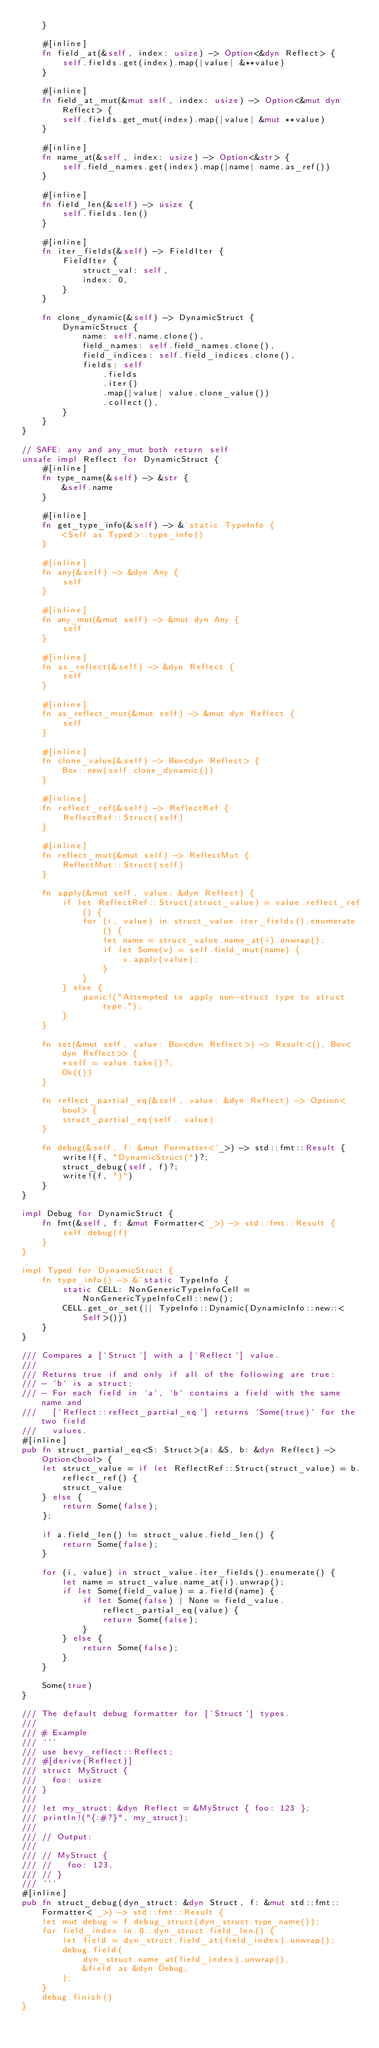Convert code to text. <code><loc_0><loc_0><loc_500><loc_500><_Rust_>    }

    #[inline]
    fn field_at(&self, index: usize) -> Option<&dyn Reflect> {
        self.fields.get(index).map(|value| &**value)
    }

    #[inline]
    fn field_at_mut(&mut self, index: usize) -> Option<&mut dyn Reflect> {
        self.fields.get_mut(index).map(|value| &mut **value)
    }

    #[inline]
    fn name_at(&self, index: usize) -> Option<&str> {
        self.field_names.get(index).map(|name| name.as_ref())
    }

    #[inline]
    fn field_len(&self) -> usize {
        self.fields.len()
    }

    #[inline]
    fn iter_fields(&self) -> FieldIter {
        FieldIter {
            struct_val: self,
            index: 0,
        }
    }

    fn clone_dynamic(&self) -> DynamicStruct {
        DynamicStruct {
            name: self.name.clone(),
            field_names: self.field_names.clone(),
            field_indices: self.field_indices.clone(),
            fields: self
                .fields
                .iter()
                .map(|value| value.clone_value())
                .collect(),
        }
    }
}

// SAFE: any and any_mut both return self
unsafe impl Reflect for DynamicStruct {
    #[inline]
    fn type_name(&self) -> &str {
        &self.name
    }

    #[inline]
    fn get_type_info(&self) -> &'static TypeInfo {
        <Self as Typed>::type_info()
    }

    #[inline]
    fn any(&self) -> &dyn Any {
        self
    }

    #[inline]
    fn any_mut(&mut self) -> &mut dyn Any {
        self
    }

    #[inline]
    fn as_reflect(&self) -> &dyn Reflect {
        self
    }

    #[inline]
    fn as_reflect_mut(&mut self) -> &mut dyn Reflect {
        self
    }

    #[inline]
    fn clone_value(&self) -> Box<dyn Reflect> {
        Box::new(self.clone_dynamic())
    }

    #[inline]
    fn reflect_ref(&self) -> ReflectRef {
        ReflectRef::Struct(self)
    }

    #[inline]
    fn reflect_mut(&mut self) -> ReflectMut {
        ReflectMut::Struct(self)
    }

    fn apply(&mut self, value: &dyn Reflect) {
        if let ReflectRef::Struct(struct_value) = value.reflect_ref() {
            for (i, value) in struct_value.iter_fields().enumerate() {
                let name = struct_value.name_at(i).unwrap();
                if let Some(v) = self.field_mut(name) {
                    v.apply(value);
                }
            }
        } else {
            panic!("Attempted to apply non-struct type to struct type.");
        }
    }

    fn set(&mut self, value: Box<dyn Reflect>) -> Result<(), Box<dyn Reflect>> {
        *self = value.take()?;
        Ok(())
    }

    fn reflect_partial_eq(&self, value: &dyn Reflect) -> Option<bool> {
        struct_partial_eq(self, value)
    }

    fn debug(&self, f: &mut Formatter<'_>) -> std::fmt::Result {
        write!(f, "DynamicStruct(")?;
        struct_debug(self, f)?;
        write!(f, ")")
    }
}

impl Debug for DynamicStruct {
    fn fmt(&self, f: &mut Formatter<'_>) -> std::fmt::Result {
        self.debug(f)
    }
}

impl Typed for DynamicStruct {
    fn type_info() -> &'static TypeInfo {
        static CELL: NonGenericTypeInfoCell = NonGenericTypeInfoCell::new();
        CELL.get_or_set(|| TypeInfo::Dynamic(DynamicInfo::new::<Self>()))
    }
}

/// Compares a [`Struct`] with a [`Reflect`] value.
///
/// Returns true if and only if all of the following are true:
/// - `b` is a struct;
/// - For each field in `a`, `b` contains a field with the same name and
///   [`Reflect::reflect_partial_eq`] returns `Some(true)` for the two field
///   values.
#[inline]
pub fn struct_partial_eq<S: Struct>(a: &S, b: &dyn Reflect) -> Option<bool> {
    let struct_value = if let ReflectRef::Struct(struct_value) = b.reflect_ref() {
        struct_value
    } else {
        return Some(false);
    };

    if a.field_len() != struct_value.field_len() {
        return Some(false);
    }

    for (i, value) in struct_value.iter_fields().enumerate() {
        let name = struct_value.name_at(i).unwrap();
        if let Some(field_value) = a.field(name) {
            if let Some(false) | None = field_value.reflect_partial_eq(value) {
                return Some(false);
            }
        } else {
            return Some(false);
        }
    }

    Some(true)
}

/// The default debug formatter for [`Struct`] types.
///
/// # Example
/// ```
/// use bevy_reflect::Reflect;
/// #[derive(Reflect)]
/// struct MyStruct {
///   foo: usize
/// }
///
/// let my_struct: &dyn Reflect = &MyStruct { foo: 123 };
/// println!("{:#?}", my_struct);
///
/// // Output:
///
/// // MyStruct {
/// //   foo: 123,
/// // }
/// ```
#[inline]
pub fn struct_debug(dyn_struct: &dyn Struct, f: &mut std::fmt::Formatter<'_>) -> std::fmt::Result {
    let mut debug = f.debug_struct(dyn_struct.type_name());
    for field_index in 0..dyn_struct.field_len() {
        let field = dyn_struct.field_at(field_index).unwrap();
        debug.field(
            dyn_struct.name_at(field_index).unwrap(),
            &field as &dyn Debug,
        );
    }
    debug.finish()
}
</code> 